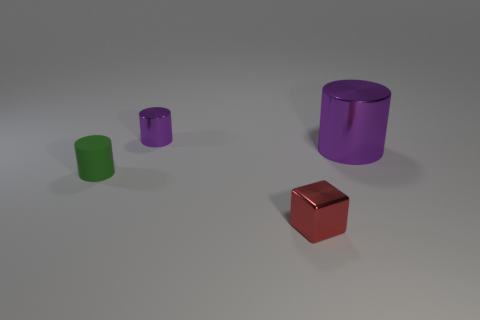What number of shiny blocks have the same size as the red object?
Provide a succinct answer. 0. The large thing that is the same color as the tiny metal cylinder is what shape?
Make the answer very short. Cylinder. Is there a small shiny thing that is to the left of the shiny cylinder that is to the right of the tiny red metal cube?
Your response must be concise. Yes. How many things are either purple things right of the tiny shiny block or cyan rubber balls?
Give a very brief answer. 1. How many metal objects are there?
Your answer should be compact. 3. What is the shape of the purple object that is the same material as the big purple cylinder?
Ensure brevity in your answer.  Cylinder. There is a shiny cylinder in front of the metallic object to the left of the small red metallic object; what size is it?
Offer a very short reply. Large. How many things are either tiny objects behind the tiny green thing or tiny rubber objects on the left side of the tiny shiny cylinder?
Make the answer very short. 2. Is the number of small brown shiny balls less than the number of green rubber things?
Provide a short and direct response. Yes. What number of objects are tiny purple rubber cubes or purple things?
Make the answer very short. 2. 